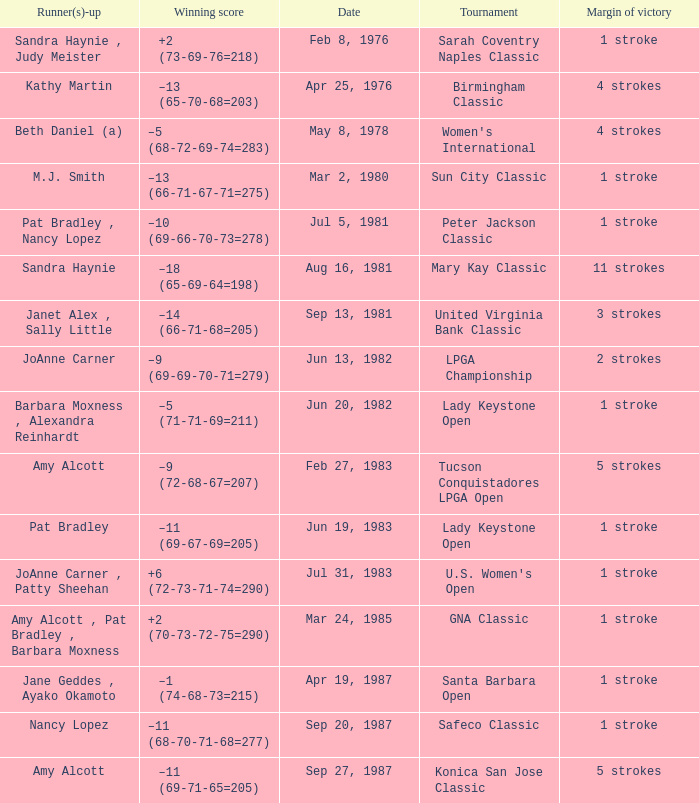What is the margin of victory when the tournament is konica san jose classic? 5 strokes. 